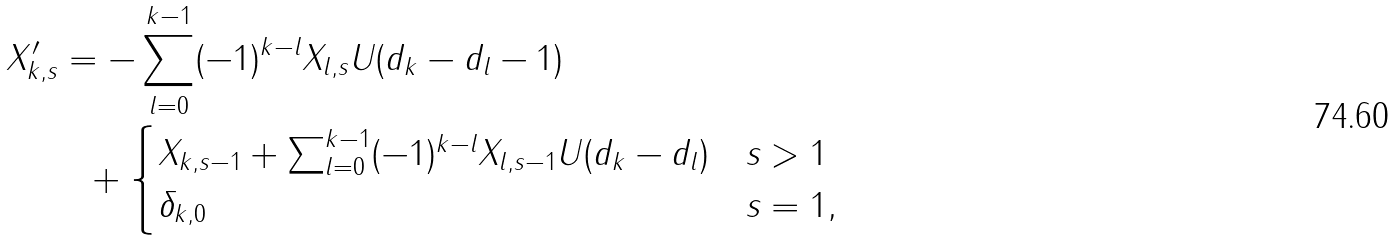Convert formula to latex. <formula><loc_0><loc_0><loc_500><loc_500>X _ { k , s } ^ { \prime } & = - \sum _ { l = 0 } ^ { k - 1 } ( - 1 ) ^ { k - l } X _ { l , s } U ( d _ { k } - d _ { l } - 1 ) \\ & \ \ + \begin{cases} X _ { k , s - 1 } + \sum _ { l = 0 } ^ { k - 1 } ( - 1 ) ^ { k - l } X _ { l , s - 1 } U ( d _ { k } - d _ { l } ) & s > 1 \\ \delta _ { k , 0 } & s = 1 , \end{cases}</formula> 